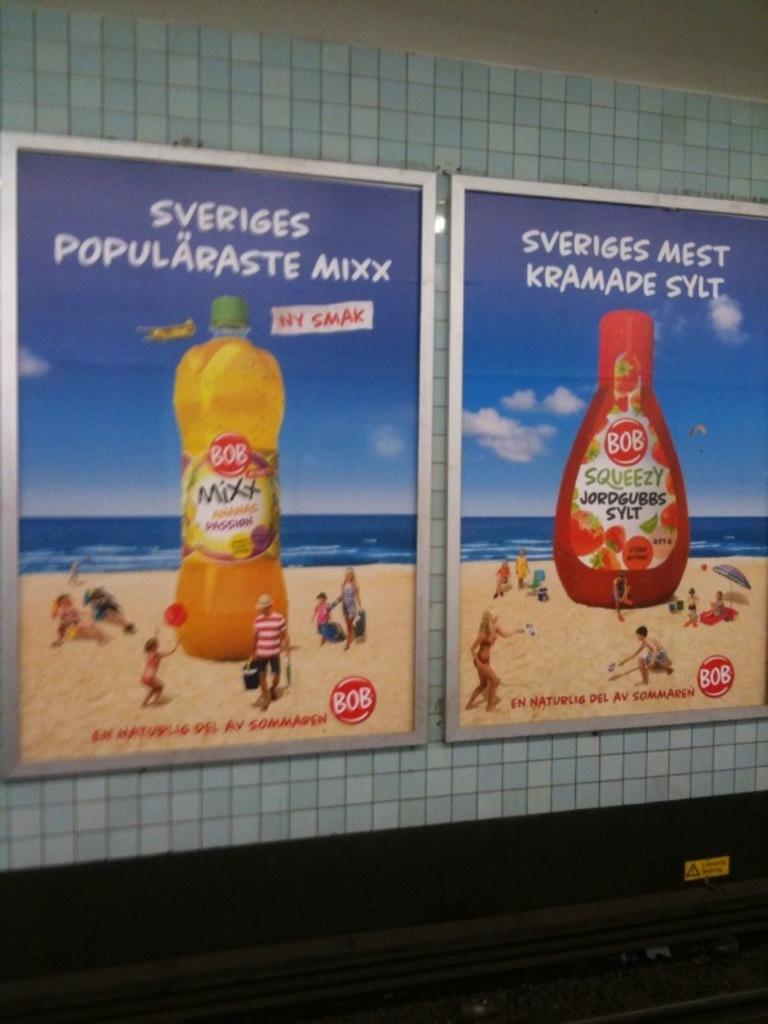What does the sign say?
Keep it short and to the point. Sveriges popularaste mixx. 